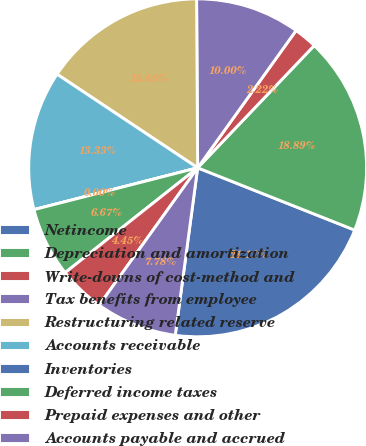Convert chart. <chart><loc_0><loc_0><loc_500><loc_500><pie_chart><fcel>Netincome<fcel>Depreciation and amortization<fcel>Write-downs of cost-method and<fcel>Tax benefits from employee<fcel>Restructuring related reserve<fcel>Accounts receivable<fcel>Inventories<fcel>Deferred income taxes<fcel>Prepaid expenses and other<fcel>Accounts payable and accrued<nl><fcel>21.11%<fcel>18.89%<fcel>2.22%<fcel>10.0%<fcel>15.55%<fcel>13.33%<fcel>0.0%<fcel>6.67%<fcel>4.45%<fcel>7.78%<nl></chart> 